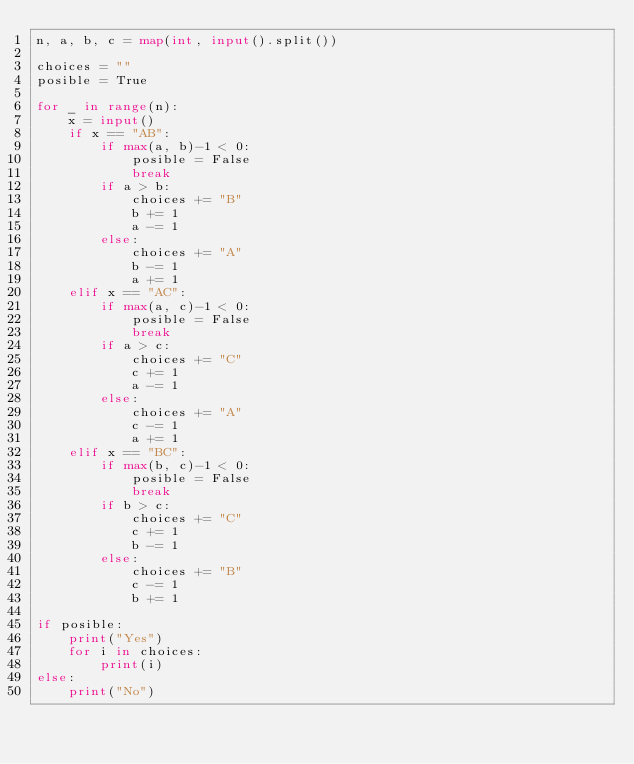Convert code to text. <code><loc_0><loc_0><loc_500><loc_500><_Python_>n, a, b, c = map(int, input().split())

choices = ""
posible = True

for _ in range(n):
	x = input()
	if x == "AB":
		if max(a, b)-1 < 0:
			posible = False
			break
		if a > b:
			choices += "B"
			b += 1
			a -= 1
		else:
			choices += "A"
			b -= 1
			a += 1
	elif x == "AC":
		if max(a, c)-1 < 0:
			posible = False
			break
		if a > c:
			choices += "C"
			c += 1
			a -= 1
		else:
			choices += "A"
			c -= 1
			a += 1
	elif x == "BC":
		if max(b, c)-1 < 0:
			posible = False
			break
		if b > c:
			choices += "C"
			c += 1
			b -= 1
		else:
			choices += "B"
			c -= 1
			b += 1

if posible:
	print("Yes")
	for i in choices:
		print(i)
else:
	print("No")
</code> 